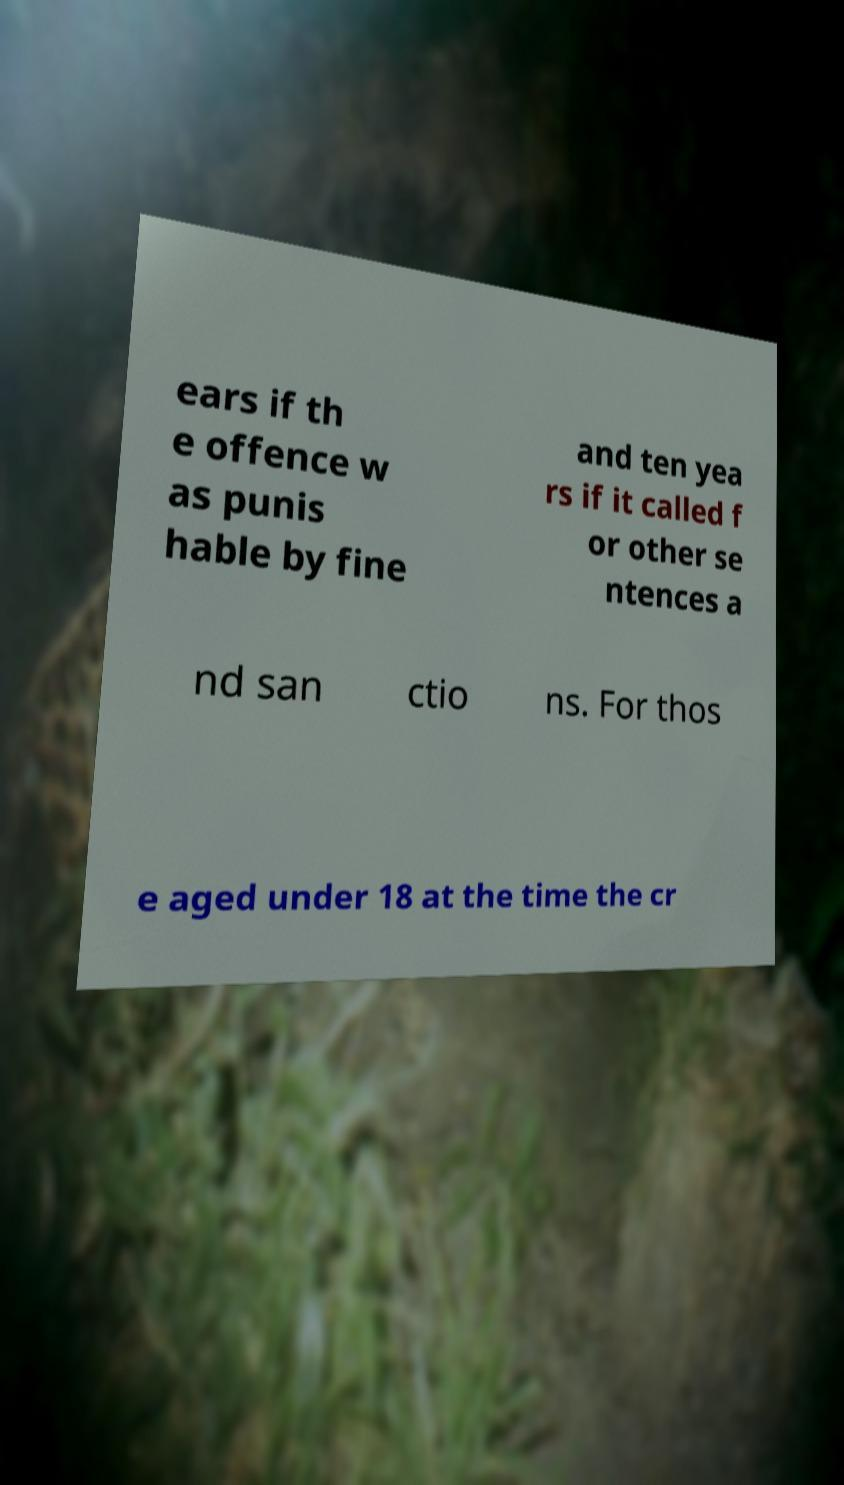Can you read and provide the text displayed in the image?This photo seems to have some interesting text. Can you extract and type it out for me? ears if th e offence w as punis hable by fine and ten yea rs if it called f or other se ntences a nd san ctio ns. For thos e aged under 18 at the time the cr 